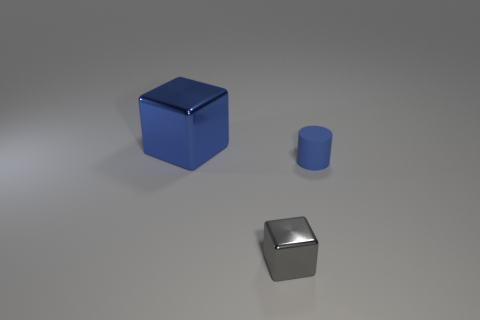Is there anything else that has the same material as the cylinder?
Your answer should be very brief. No. Is there any other thing that has the same shape as the tiny rubber object?
Your answer should be very brief. No. What number of other objects are there of the same color as the tiny cube?
Offer a very short reply. 0. There is a gray metallic thing that is the same size as the blue matte thing; what is its shape?
Offer a very short reply. Cube. What is the color of the metallic cube that is on the right side of the large blue thing?
Your response must be concise. Gray. What number of things are shiny things to the left of the gray cube or metal cubes that are behind the cylinder?
Make the answer very short. 1. Do the matte object and the blue shiny object have the same size?
Your answer should be very brief. No. What number of blocks are big blue objects or blue objects?
Give a very brief answer. 1. What number of blue things are both on the right side of the tiny gray metallic cube and behind the tiny blue object?
Ensure brevity in your answer.  0. Do the matte thing and the block that is behind the tiny blue matte object have the same size?
Keep it short and to the point. No. 